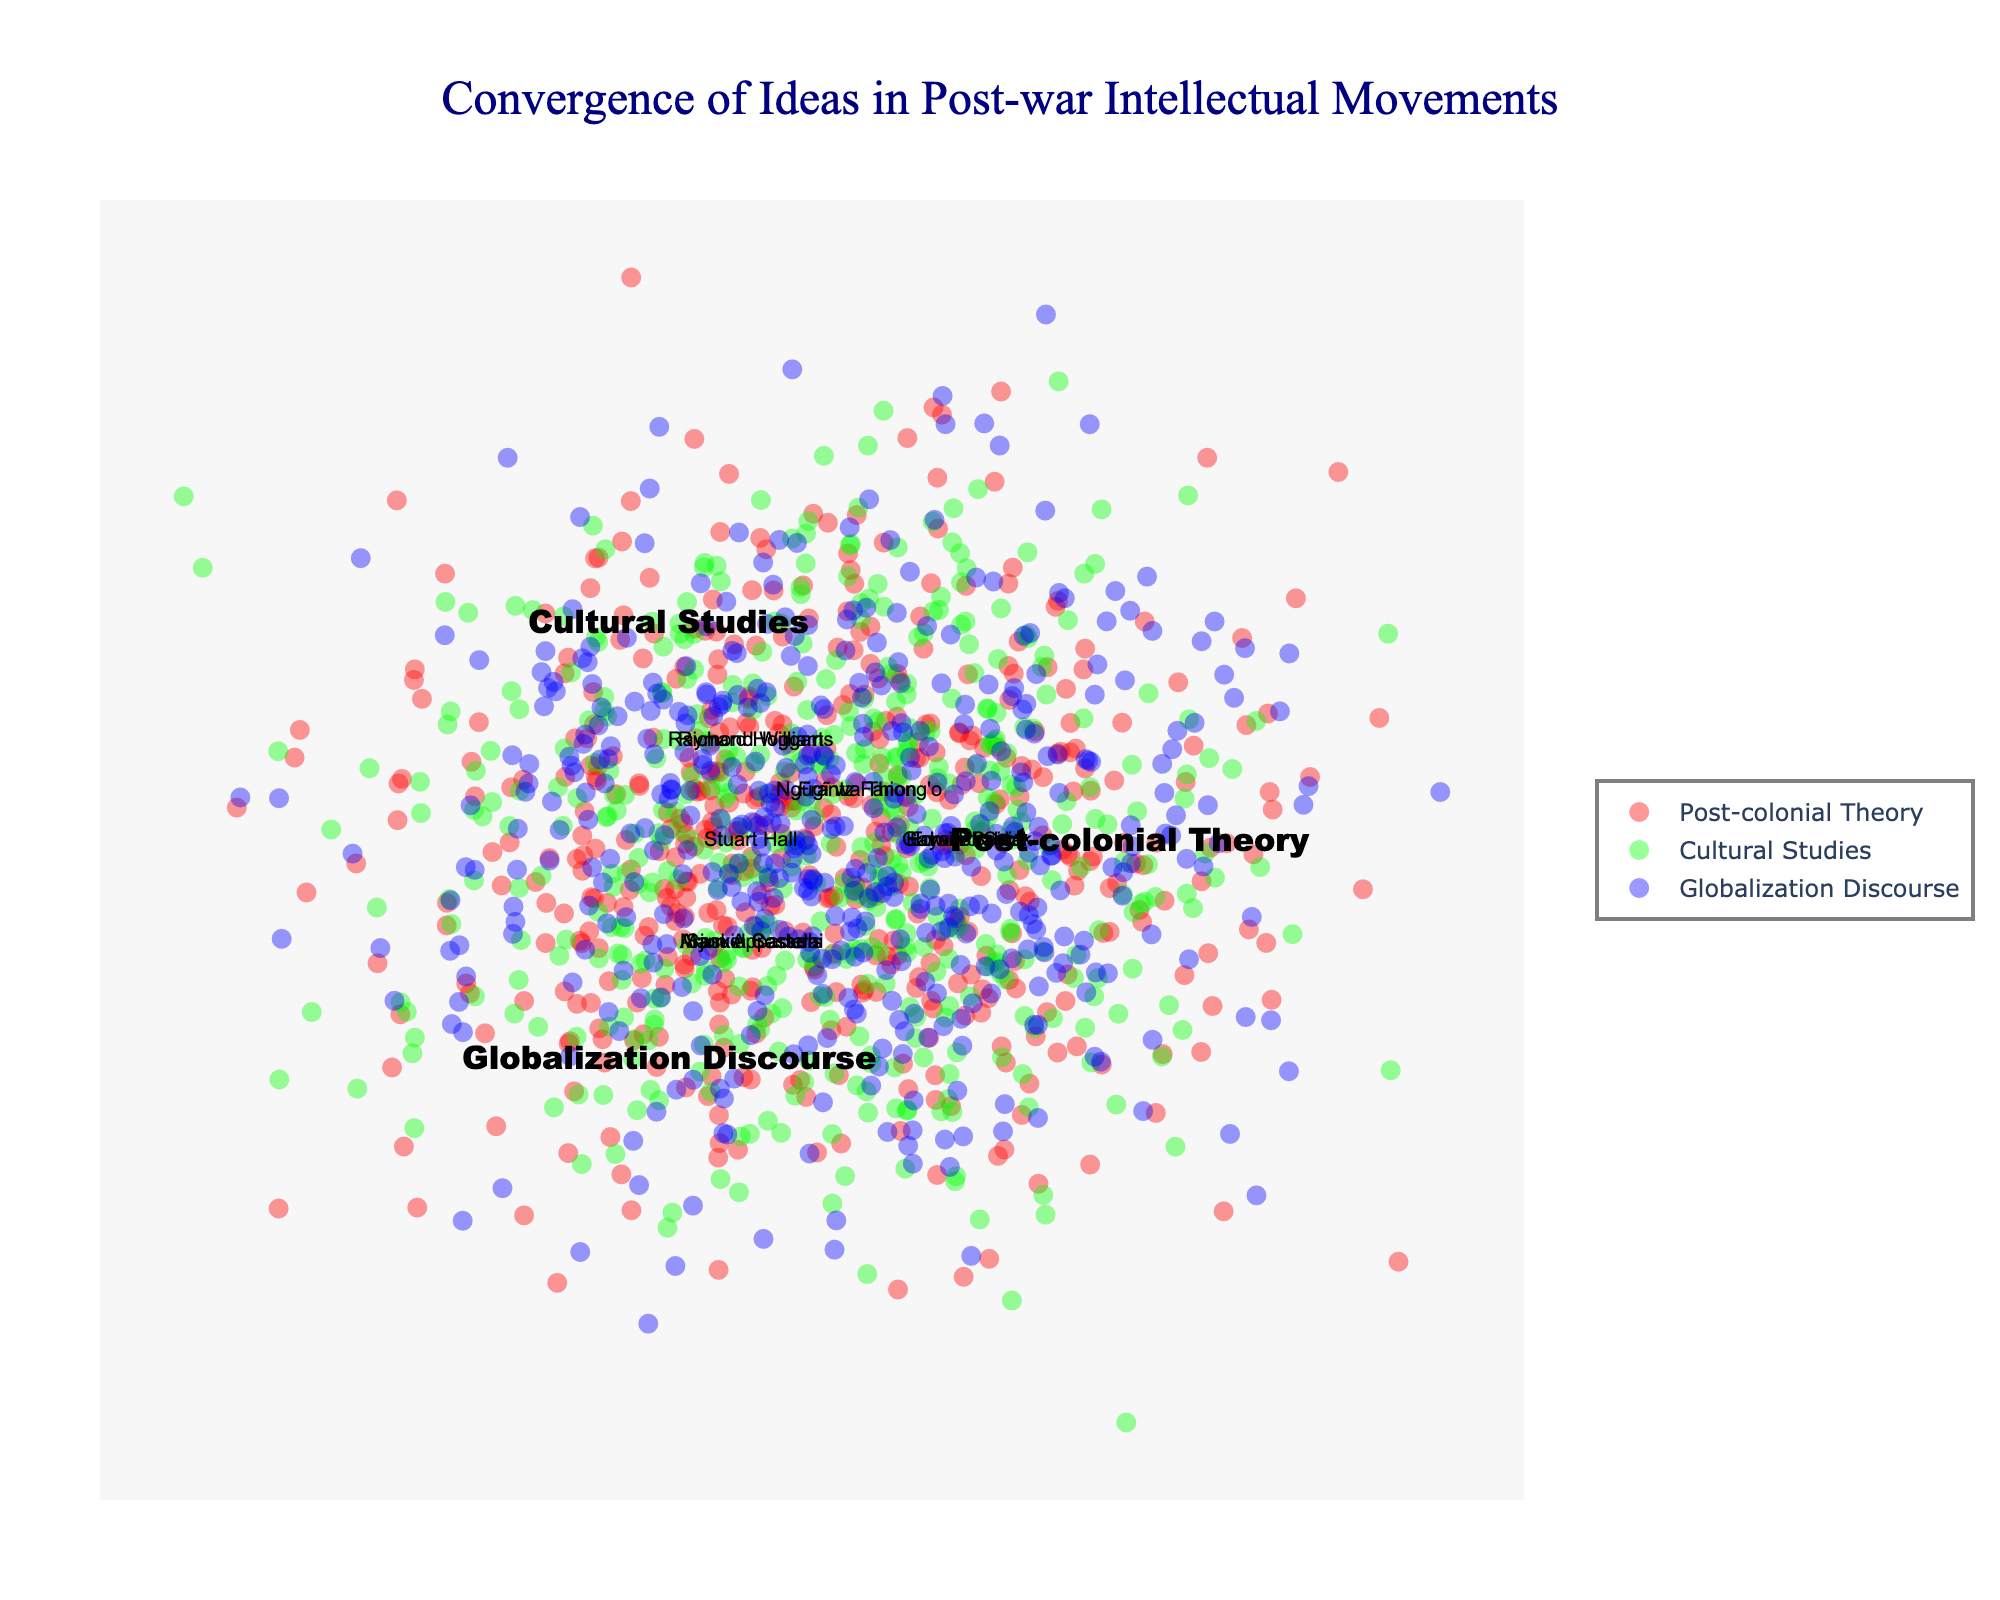What's the main title of the figure? The main title of the figure is usually located at the top center of the diagram. It describes the overall subject being visualized.
Answer: Convergence of Ideas in Post-war Intellectual Movements Which theorists fall under only Post-colonial Theory? Look at the isolated section labeled "Post-colonial Theory" where no other circles intersect. The names in this section fall under Post-colonial Theory exclusively.
Answer: Edward Said, Homi Bhabha, Gayatri Spivak How many theorists are shared between Cultural Studies and Globalization Discourse? Identify the section where the circles of Cultural Studies and Globalization Discourse intersect without including Post-colonial Theory. Count the names within this overlapping section.
Answer: 1 Name a theorist contributing to all three intellectual movements. Look at the center of the Venn diagram where all three circles overlap. The names in this intersection are contributors to Post-colonial Theory, Cultural Studies, and Globalization Discourse.
Answer: Immanuel Wallerstein, Dipesh Chakrabarty, Ulf Hannerz How many theorists are associated with both Post-colonial Theory and Cultural Studies? Identify the overlapping area between Post-colonial Theory and Cultural Studies without including Globalization Discourse. Count the number of theorists in this particular section.
Answer: 2 Compare the number of theorists exclusively in Cultural Studies versus those exclusively in Globalization Discourse. Which has more? Count the names in the exclusive section for Cultural Studies and compare it with the exclusive section for Globalization Discourse. Determine which count is higher.
Answer: Globalization Discourse Who are the theorists that appear in the Globalization Discourse circle? Look at both the intersection areas and the exclusive section of the Globalization Discourse circle to identify all theorists associated with it.
Answer: Arjun Appadurai, Saskia Sassen, Manuel Castells, Stuart Hall, Immanuel Wallerstein, Dipesh Chakrabarty, Ulf Hannerz Identify a theorist that bridges Post-colonial Theory and Globalization Discourse but not Cultural Studies. Look at the overlapping section between Post-colonial Theory and Globalization Discourse without including Cultural Studies. Identify the names there.
Answer: None Is there a theorist who overlaps between Cultural Studies and Post-colonial Theory but does not appear in the Globalization Discourse? Check the area where Cultural Studies and Post-colonial Theory overlap exclusively, excluding any names also appearing in Globalization Discourse.
Answer: Frantz Fanon, Ngũgĩ wa Thiong'o 